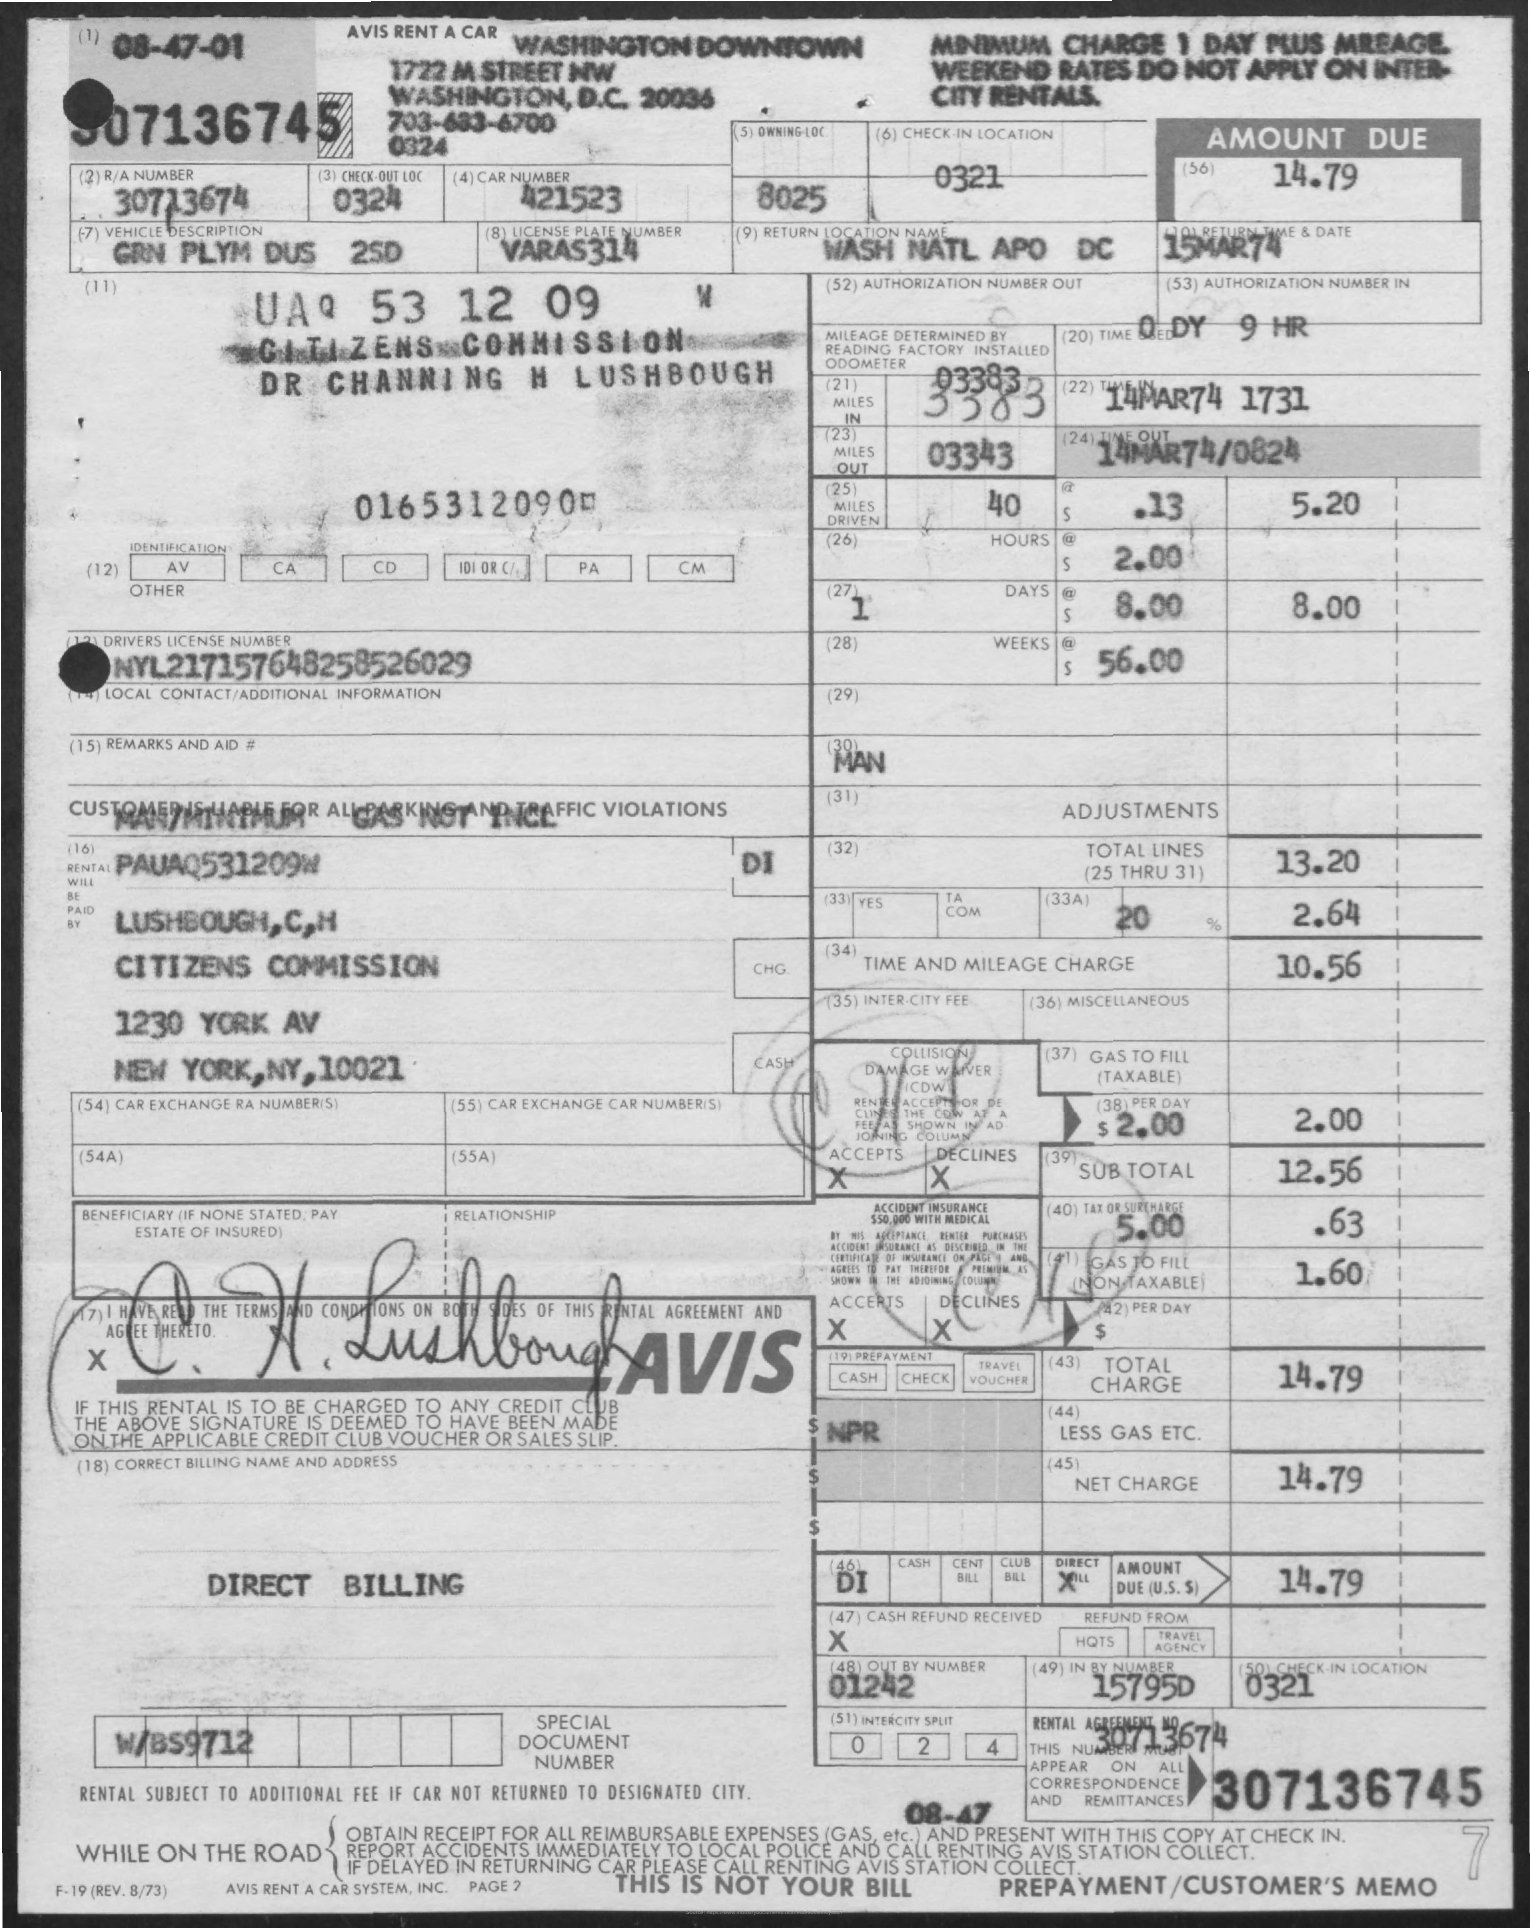What is the car number? The car number, as indicated on the rental agreement, is 421523. 